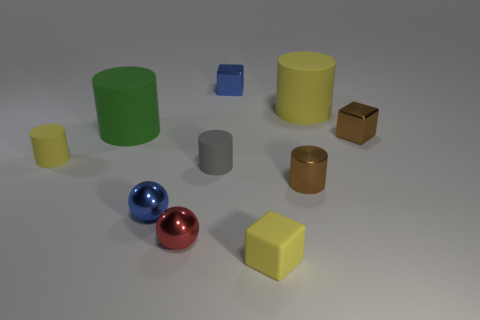There is a matte cylinder in front of the yellow object that is to the left of the tiny blue shiny sphere; are there any metal objects that are behind it?
Your response must be concise. Yes. What is the shape of the gray rubber object that is the same size as the red object?
Your answer should be very brief. Cylinder. What number of big things are brown cylinders or brown shiny blocks?
Make the answer very short. 0. What color is the other big thing that is made of the same material as the big green thing?
Your answer should be very brief. Yellow. Is the shape of the big object that is right of the tiny red metallic sphere the same as the small brown thing that is to the right of the tiny brown cylinder?
Keep it short and to the point. No. What number of rubber objects are big cyan cylinders or spheres?
Give a very brief answer. 0. There is a thing that is the same color as the small metallic cylinder; what is it made of?
Your response must be concise. Metal. Is there anything else that has the same shape as the large green thing?
Make the answer very short. Yes. There is a tiny brown object behind the tiny gray matte cylinder; what material is it?
Keep it short and to the point. Metal. Is the material of the yellow thing in front of the blue ball the same as the tiny blue ball?
Ensure brevity in your answer.  No. 